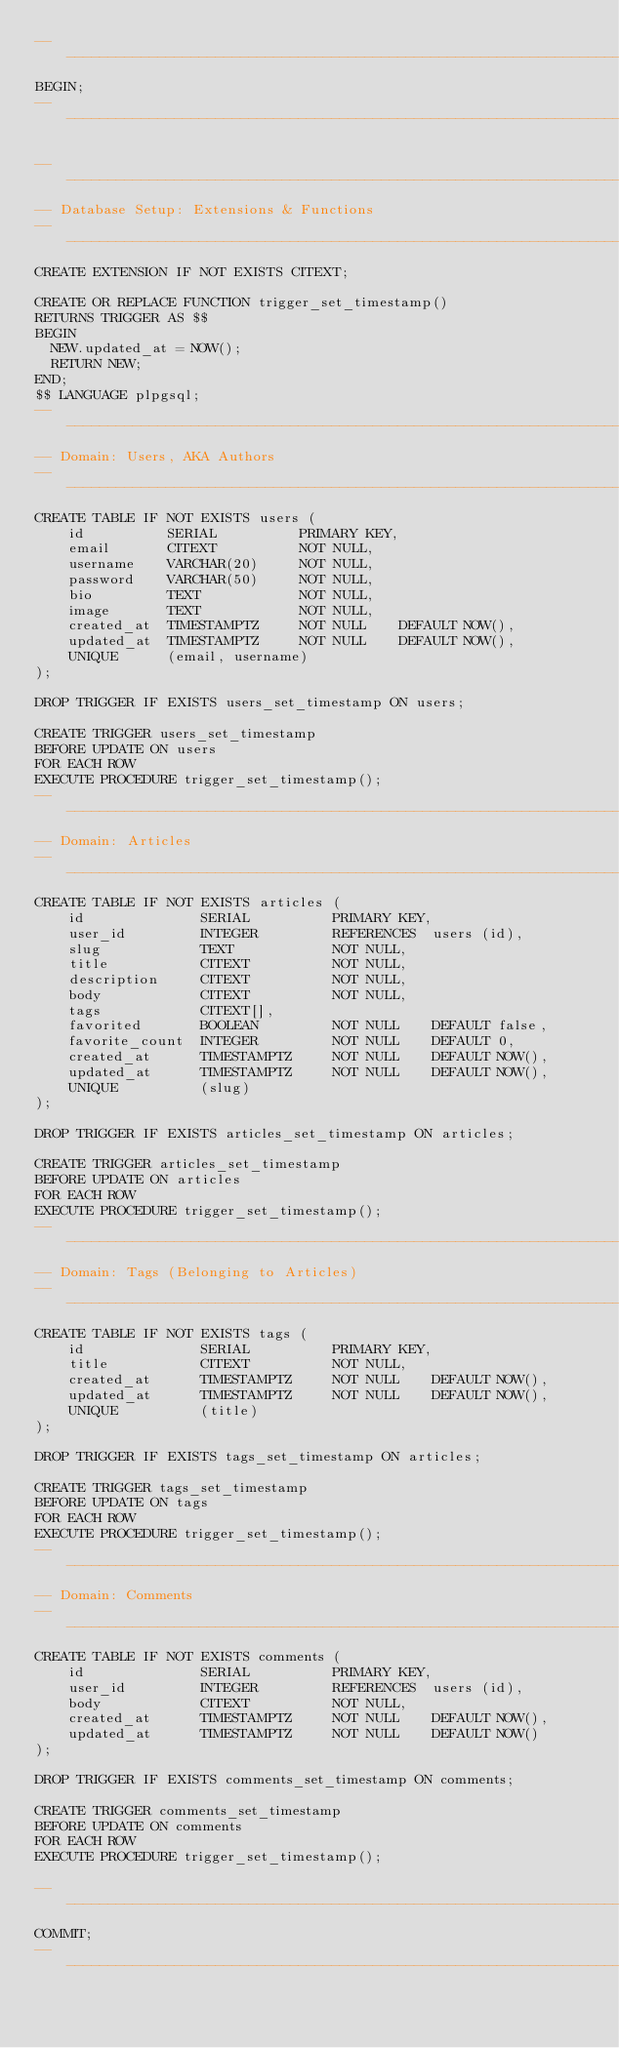<code> <loc_0><loc_0><loc_500><loc_500><_SQL_>--------------------------------------------------------------------------------
BEGIN;
--------------------------------------------------------------------------------

--------------------------------------------------------------------------------
-- Database Setup: Extensions & Functions
--------------------------------------------------------------------------------
CREATE EXTENSION IF NOT EXISTS CITEXT;

CREATE OR REPLACE FUNCTION trigger_set_timestamp()
RETURNS TRIGGER AS $$
BEGIN
  NEW.updated_at = NOW();
  RETURN NEW;
END;
$$ LANGUAGE plpgsql;
--------------------------------------------------------------------------------
-- Domain: Users, AKA Authors
--------------------------------------------------------------------------------
CREATE TABLE IF NOT EXISTS users (
    id          SERIAL          PRIMARY KEY,
    email       CITEXT          NOT NULL,
    username    VARCHAR(20)     NOT NULL,
    password    VARCHAR(50)     NOT NULL,
    bio         TEXT            NOT NULL,
    image       TEXT            NOT NULL,
    created_at  TIMESTAMPTZ     NOT NULL    DEFAULT NOW(),
    updated_at  TIMESTAMPTZ     NOT NULL    DEFAULT NOW(),
    UNIQUE      (email, username)
);

DROP TRIGGER IF EXISTS users_set_timestamp ON users;

CREATE TRIGGER users_set_timestamp
BEFORE UPDATE ON users
FOR EACH ROW
EXECUTE PROCEDURE trigger_set_timestamp();
--------------------------------------------------------------------------------
-- Domain: Articles
--------------------------------------------------------------------------------
CREATE TABLE IF NOT EXISTS articles (
    id              SERIAL          PRIMARY KEY,
    user_id         INTEGER         REFERENCES  users (id),
    slug            TEXT            NOT NULL,
    title           CITEXT          NOT NULL,
    description     CITEXT          NOT NULL,
    body            CITEXT          NOT NULL,
    tags            CITEXT[],
    favorited       BOOLEAN         NOT NULL    DEFAULT false,
    favorite_count  INTEGER         NOT NULL    DEFAULT 0,
    created_at      TIMESTAMPTZ     NOT NULL    DEFAULT NOW(),
    updated_at      TIMESTAMPTZ     NOT NULL    DEFAULT NOW(),
    UNIQUE          (slug)
);

DROP TRIGGER IF EXISTS articles_set_timestamp ON articles;

CREATE TRIGGER articles_set_timestamp
BEFORE UPDATE ON articles
FOR EACH ROW
EXECUTE PROCEDURE trigger_set_timestamp();
--------------------------------------------------------------------------------
-- Domain: Tags (Belonging to Articles)
--------------------------------------------------------------------------------
CREATE TABLE IF NOT EXISTS tags (
    id              SERIAL          PRIMARY KEY,
    title           CITEXT          NOT NULL,
    created_at      TIMESTAMPTZ     NOT NULL    DEFAULT NOW(),
    updated_at      TIMESTAMPTZ     NOT NULL    DEFAULT NOW(),
    UNIQUE          (title)
);

DROP TRIGGER IF EXISTS tags_set_timestamp ON articles;

CREATE TRIGGER tags_set_timestamp
BEFORE UPDATE ON tags
FOR EACH ROW
EXECUTE PROCEDURE trigger_set_timestamp();
--------------------------------------------------------------------------------
-- Domain: Comments
--------------------------------------------------------------------------------
CREATE TABLE IF NOT EXISTS comments (
    id              SERIAL          PRIMARY KEY,
    user_id         INTEGER         REFERENCES  users (id),
    body            CITEXT          NOT NULL,
    created_at      TIMESTAMPTZ     NOT NULL    DEFAULT NOW(),
    updated_at      TIMESTAMPTZ     NOT NULL    DEFAULT NOW()
);

DROP TRIGGER IF EXISTS comments_set_timestamp ON comments;

CREATE TRIGGER comments_set_timestamp
BEFORE UPDATE ON comments
FOR EACH ROW
EXECUTE PROCEDURE trigger_set_timestamp();

--------------------------------------------------------------------------------
COMMIT;
--------------------------------------------------------------------------------</code> 